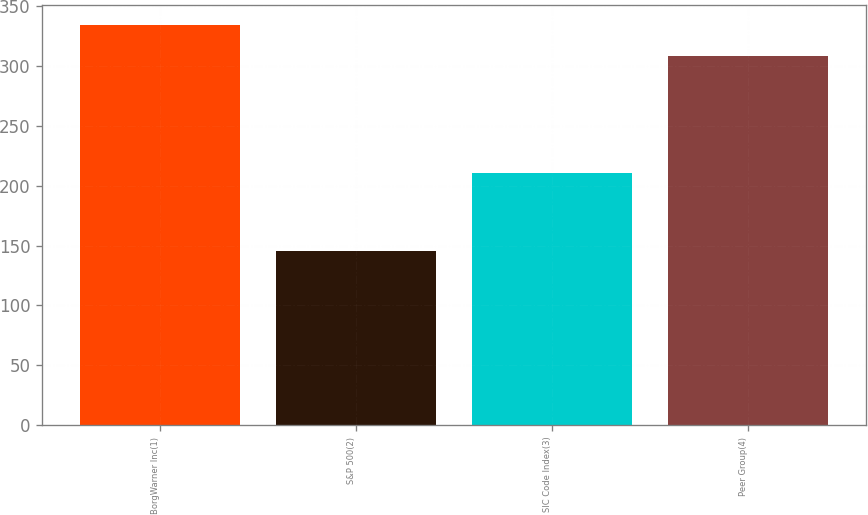Convert chart. <chart><loc_0><loc_0><loc_500><loc_500><bar_chart><fcel>BorgWarner Inc(1)<fcel>S&P 500(2)<fcel>SIC Code Index(3)<fcel>Peer Group(4)<nl><fcel>334.6<fcel>145.51<fcel>210.59<fcel>308.11<nl></chart> 